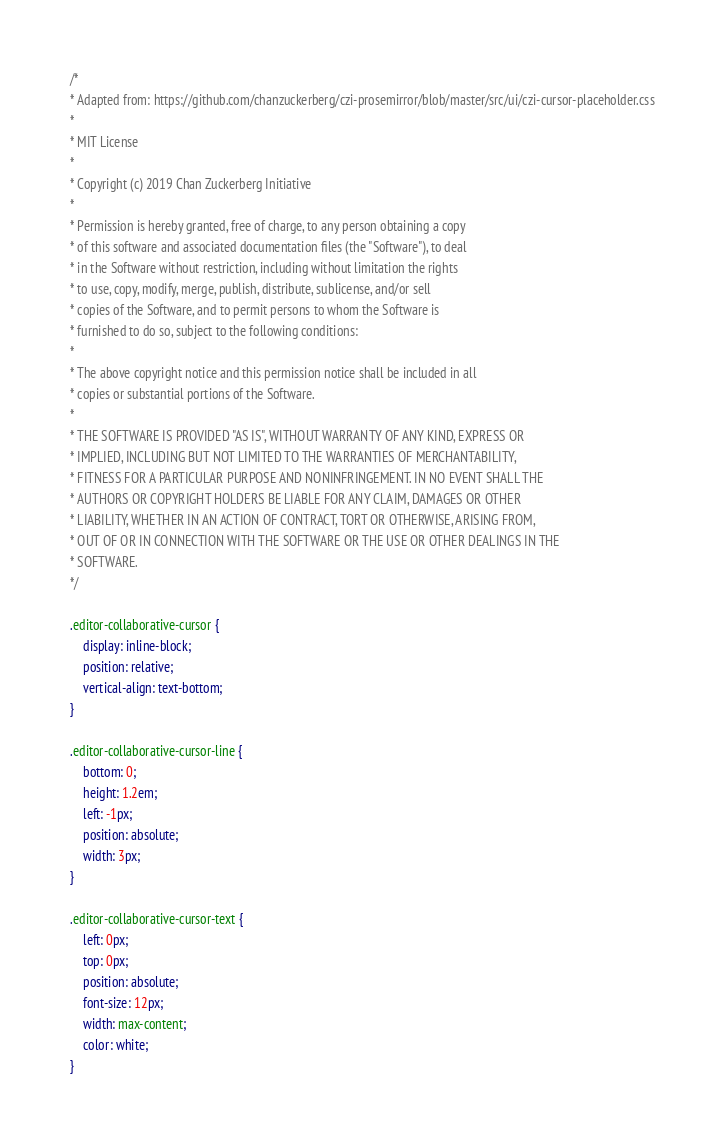<code> <loc_0><loc_0><loc_500><loc_500><_CSS_>/*
* Adapted from: https://github.com/chanzuckerberg/czi-prosemirror/blob/master/src/ui/czi-cursor-placeholder.css
*
* MIT License
*
* Copyright (c) 2019 Chan Zuckerberg Initiative
*
* Permission is hereby granted, free of charge, to any person obtaining a copy
* of this software and associated documentation files (the "Software"), to deal
* in the Software without restriction, including without limitation the rights
* to use, copy, modify, merge, publish, distribute, sublicense, and/or sell
* copies of the Software, and to permit persons to whom the Software is
* furnished to do so, subject to the following conditions:
*
* The above copyright notice and this permission notice shall be included in all
* copies or substantial portions of the Software.
*
* THE SOFTWARE IS PROVIDED "AS IS", WITHOUT WARRANTY OF ANY KIND, EXPRESS OR
* IMPLIED, INCLUDING BUT NOT LIMITED TO THE WARRANTIES OF MERCHANTABILITY,
* FITNESS FOR A PARTICULAR PURPOSE AND NONINFRINGEMENT. IN NO EVENT SHALL THE
* AUTHORS OR COPYRIGHT HOLDERS BE LIABLE FOR ANY CLAIM, DAMAGES OR OTHER
* LIABILITY, WHETHER IN AN ACTION OF CONTRACT, TORT OR OTHERWISE, ARISING FROM,
* OUT OF OR IN CONNECTION WITH THE SOFTWARE OR THE USE OR OTHER DEALINGS IN THE
* SOFTWARE.
*/

.editor-collaborative-cursor {
	display: inline-block;
	position: relative;
	vertical-align: text-bottom;
}

.editor-collaborative-cursor-line {
	bottom: 0;
	height: 1.2em;
	left: -1px;
	position: absolute;
	width: 3px;
}

.editor-collaborative-cursor-text {
	left: 0px;
	top: 0px;
	position: absolute;
	font-size: 12px;
	width: max-content;
	color: white;
}
</code> 